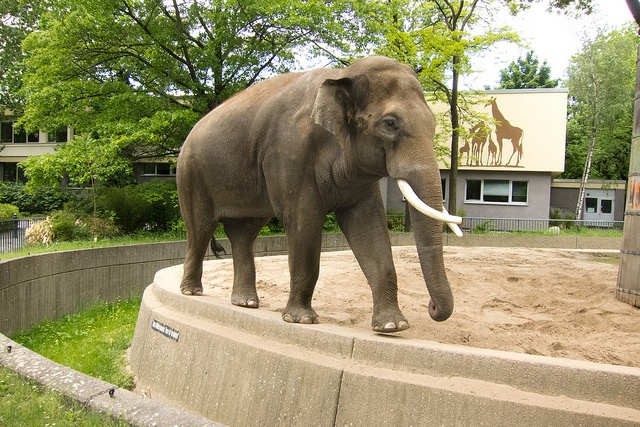Describe the objects in this image and their specific colors. I can see elephant in darkgreen, gray, black, and tan tones, giraffe in darkgreen, tan, khaki, and beige tones, giraffe in darkgreen, gray, tan, and darkgray tones, and giraffe in darkgreen, gray, olive, and tan tones in this image. 